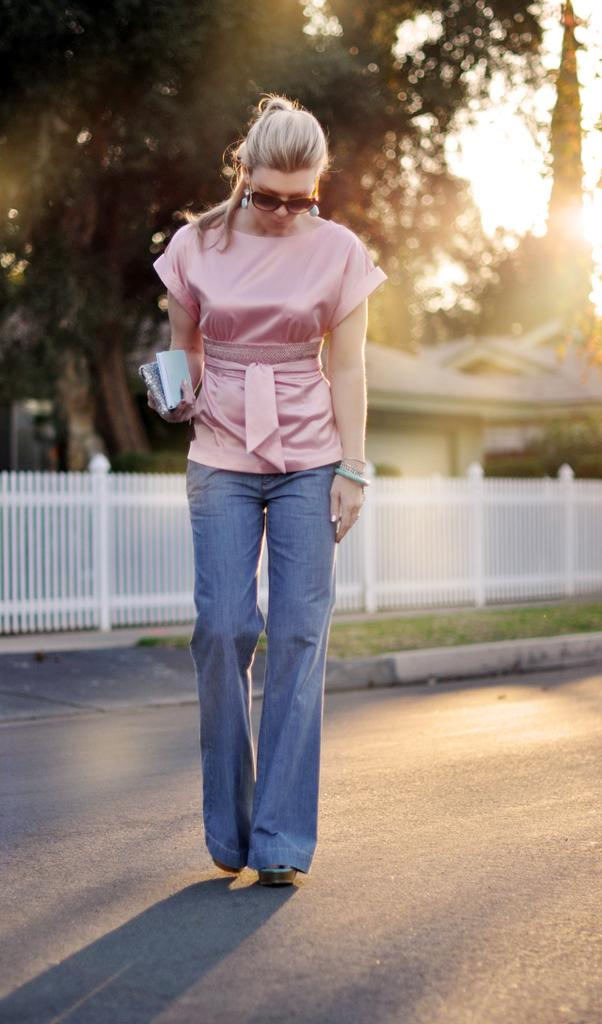Who is the main subject in the image? There is a woman in the image. What is the woman wearing? The woman is wearing a pink top and blue jeans. What is the woman doing in the image? The woman is walking on the road. What can be seen in the background of the image? There is a fence, a tree, and houses in the background of the image. How far away is the writer from the woman in the image? There is no writer present in the image, so it is not possible to determine the distance between them. 